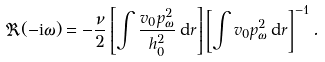<formula> <loc_0><loc_0><loc_500><loc_500>\Re ( - { \mathrm i } \omega ) = - \frac { \nu } { 2 } \left [ \int \frac { v _ { 0 } p _ { \omega } ^ { 2 } } { h _ { 0 } ^ { 2 } } \, { \mathrm d } r \right ] \left [ \int v _ { 0 } p _ { \omega } ^ { 2 } \, { \mathrm d } r \right ] ^ { - 1 } .</formula> 